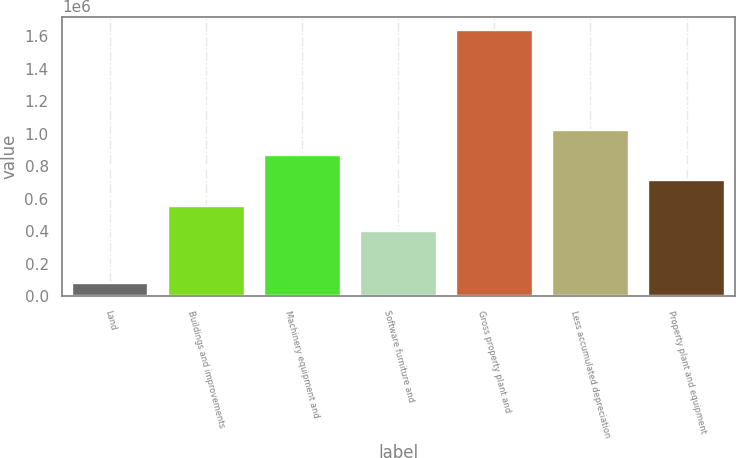<chart> <loc_0><loc_0><loc_500><loc_500><bar_chart><fcel>Land<fcel>Buildings and improvements<fcel>Machinery equipment and<fcel>Software furniture and<fcel>Gross property plant and<fcel>Less accumulated depreciation<fcel>Property plant and equipment<nl><fcel>84551<fcel>558136<fcel>869191<fcel>402608<fcel>1.63983e+06<fcel>1.02472e+06<fcel>713664<nl></chart> 